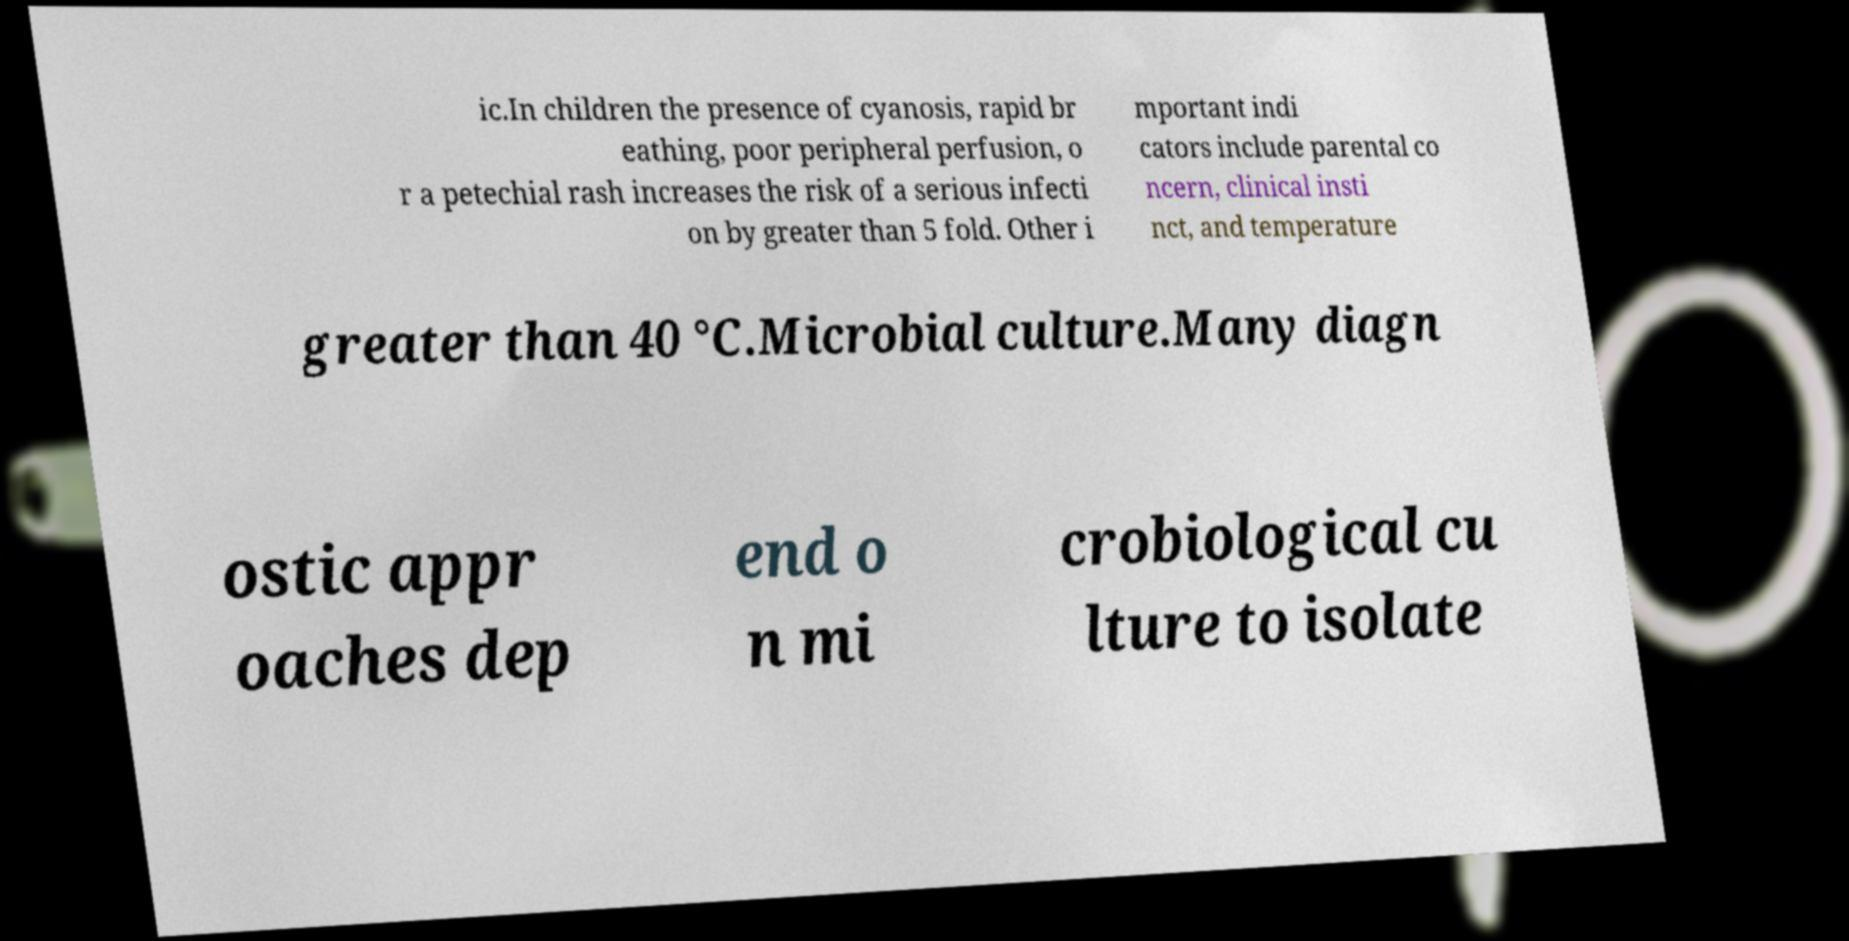I need the written content from this picture converted into text. Can you do that? ic.In children the presence of cyanosis, rapid br eathing, poor peripheral perfusion, o r a petechial rash increases the risk of a serious infecti on by greater than 5 fold. Other i mportant indi cators include parental co ncern, clinical insti nct, and temperature greater than 40 °C.Microbial culture.Many diagn ostic appr oaches dep end o n mi crobiological cu lture to isolate 